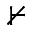<formula> <loc_0><loc_0><loc_500><loc_500>\nvdash</formula> 